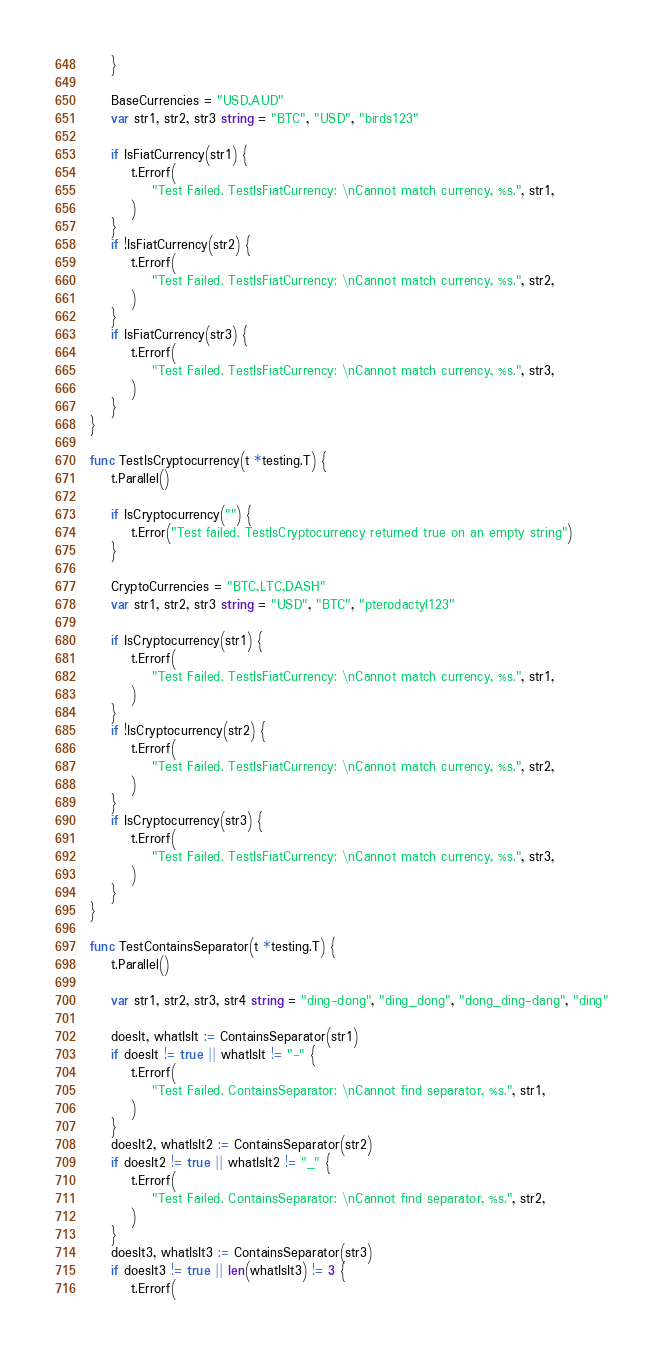Convert code to text. <code><loc_0><loc_0><loc_500><loc_500><_Go_>	}

	BaseCurrencies = "USD,AUD"
	var str1, str2, str3 string = "BTC", "USD", "birds123"

	if IsFiatCurrency(str1) {
		t.Errorf(
			"Test Failed. TestIsFiatCurrency: \nCannot match currency, %s.", str1,
		)
	}
	if !IsFiatCurrency(str2) {
		t.Errorf(
			"Test Failed. TestIsFiatCurrency: \nCannot match currency, %s.", str2,
		)
	}
	if IsFiatCurrency(str3) {
		t.Errorf(
			"Test Failed. TestIsFiatCurrency: \nCannot match currency, %s.", str3,
		)
	}
}

func TestIsCryptocurrency(t *testing.T) {
	t.Parallel()

	if IsCryptocurrency("") {
		t.Error("Test failed. TestIsCryptocurrency returned true on an empty string")
	}

	CryptoCurrencies = "BTC,LTC,DASH"
	var str1, str2, str3 string = "USD", "BTC", "pterodactyl123"

	if IsCryptocurrency(str1) {
		t.Errorf(
			"Test Failed. TestIsFiatCurrency: \nCannot match currency, %s.", str1,
		)
	}
	if !IsCryptocurrency(str2) {
		t.Errorf(
			"Test Failed. TestIsFiatCurrency: \nCannot match currency, %s.", str2,
		)
	}
	if IsCryptocurrency(str3) {
		t.Errorf(
			"Test Failed. TestIsFiatCurrency: \nCannot match currency, %s.", str3,
		)
	}
}

func TestContainsSeparator(t *testing.T) {
	t.Parallel()

	var str1, str2, str3, str4 string = "ding-dong", "ding_dong", "dong_ding-dang", "ding"

	doesIt, whatIsIt := ContainsSeparator(str1)
	if doesIt != true || whatIsIt != "-" {
		t.Errorf(
			"Test Failed. ContainsSeparator: \nCannot find separator, %s.", str1,
		)
	}
	doesIt2, whatIsIt2 := ContainsSeparator(str2)
	if doesIt2 != true || whatIsIt2 != "_" {
		t.Errorf(
			"Test Failed. ContainsSeparator: \nCannot find separator, %s.", str2,
		)
	}
	doesIt3, whatIsIt3 := ContainsSeparator(str3)
	if doesIt3 != true || len(whatIsIt3) != 3 {
		t.Errorf(</code> 